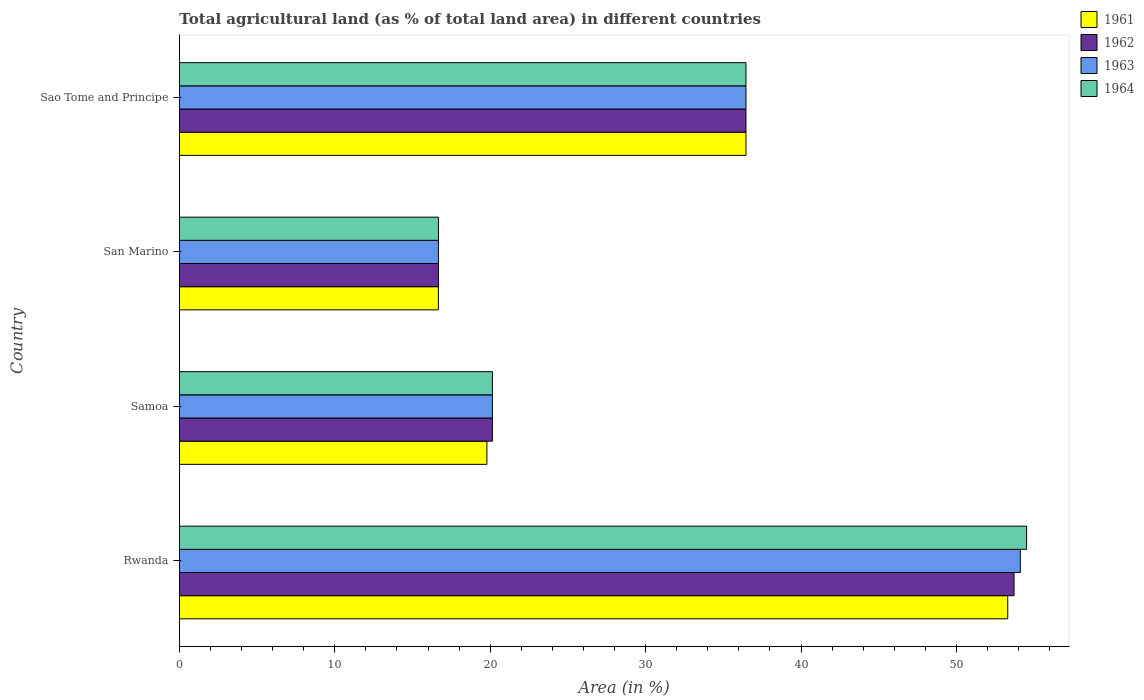Are the number of bars per tick equal to the number of legend labels?
Offer a very short reply. Yes. How many bars are there on the 4th tick from the top?
Your answer should be very brief. 4. How many bars are there on the 1st tick from the bottom?
Your response must be concise. 4. What is the label of the 1st group of bars from the top?
Ensure brevity in your answer.  Sao Tome and Principe. What is the percentage of agricultural land in 1963 in San Marino?
Your answer should be very brief. 16.67. Across all countries, what is the maximum percentage of agricultural land in 1963?
Make the answer very short. 54.11. Across all countries, what is the minimum percentage of agricultural land in 1963?
Your answer should be very brief. 16.67. In which country was the percentage of agricultural land in 1961 maximum?
Your answer should be very brief. Rwanda. In which country was the percentage of agricultural land in 1964 minimum?
Your response must be concise. San Marino. What is the total percentage of agricultural land in 1961 in the graph?
Make the answer very short. 126.22. What is the difference between the percentage of agricultural land in 1961 in Samoa and that in San Marino?
Provide a short and direct response. 3.12. What is the difference between the percentage of agricultural land in 1964 in San Marino and the percentage of agricultural land in 1961 in Rwanda?
Your response must be concise. -36.64. What is the average percentage of agricultural land in 1961 per country?
Provide a short and direct response. 31.55. What is the difference between the percentage of agricultural land in 1964 and percentage of agricultural land in 1961 in Samoa?
Make the answer very short. 0.35. What is the ratio of the percentage of agricultural land in 1962 in Rwanda to that in Sao Tome and Principe?
Your answer should be compact. 1.47. What is the difference between the highest and the second highest percentage of agricultural land in 1962?
Keep it short and to the point. 17.25. What is the difference between the highest and the lowest percentage of agricultural land in 1964?
Keep it short and to the point. 37.85. Is the sum of the percentage of agricultural land in 1961 in Rwanda and Sao Tome and Principe greater than the maximum percentage of agricultural land in 1962 across all countries?
Offer a terse response. Yes. What does the 4th bar from the top in Rwanda represents?
Give a very brief answer. 1961. Is it the case that in every country, the sum of the percentage of agricultural land in 1964 and percentage of agricultural land in 1962 is greater than the percentage of agricultural land in 1961?
Provide a succinct answer. Yes. How many countries are there in the graph?
Make the answer very short. 4. Does the graph contain grids?
Your answer should be compact. No. Where does the legend appear in the graph?
Give a very brief answer. Top right. What is the title of the graph?
Offer a very short reply. Total agricultural land (as % of total land area) in different countries. Does "1982" appear as one of the legend labels in the graph?
Keep it short and to the point. No. What is the label or title of the X-axis?
Provide a short and direct response. Area (in %). What is the Area (in %) of 1961 in Rwanda?
Offer a terse response. 53.3. What is the Area (in %) in 1962 in Rwanda?
Your response must be concise. 53.71. What is the Area (in %) of 1963 in Rwanda?
Ensure brevity in your answer.  54.11. What is the Area (in %) of 1964 in Rwanda?
Give a very brief answer. 54.52. What is the Area (in %) of 1961 in Samoa?
Ensure brevity in your answer.  19.79. What is the Area (in %) in 1962 in Samoa?
Your response must be concise. 20.14. What is the Area (in %) of 1963 in Samoa?
Your answer should be very brief. 20.14. What is the Area (in %) in 1964 in Samoa?
Your answer should be compact. 20.14. What is the Area (in %) in 1961 in San Marino?
Keep it short and to the point. 16.67. What is the Area (in %) of 1962 in San Marino?
Provide a succinct answer. 16.67. What is the Area (in %) of 1963 in San Marino?
Your response must be concise. 16.67. What is the Area (in %) in 1964 in San Marino?
Ensure brevity in your answer.  16.67. What is the Area (in %) in 1961 in Sao Tome and Principe?
Your answer should be compact. 36.46. What is the Area (in %) in 1962 in Sao Tome and Principe?
Your response must be concise. 36.46. What is the Area (in %) in 1963 in Sao Tome and Principe?
Provide a short and direct response. 36.46. What is the Area (in %) in 1964 in Sao Tome and Principe?
Your answer should be very brief. 36.46. Across all countries, what is the maximum Area (in %) in 1961?
Make the answer very short. 53.3. Across all countries, what is the maximum Area (in %) of 1962?
Your answer should be very brief. 53.71. Across all countries, what is the maximum Area (in %) of 1963?
Offer a terse response. 54.11. Across all countries, what is the maximum Area (in %) in 1964?
Provide a short and direct response. 54.52. Across all countries, what is the minimum Area (in %) in 1961?
Keep it short and to the point. 16.67. Across all countries, what is the minimum Area (in %) of 1962?
Your answer should be very brief. 16.67. Across all countries, what is the minimum Area (in %) in 1963?
Offer a terse response. 16.67. Across all countries, what is the minimum Area (in %) of 1964?
Your response must be concise. 16.67. What is the total Area (in %) in 1961 in the graph?
Offer a very short reply. 126.22. What is the total Area (in %) of 1962 in the graph?
Provide a succinct answer. 126.98. What is the total Area (in %) of 1963 in the graph?
Keep it short and to the point. 127.38. What is the total Area (in %) in 1964 in the graph?
Your answer should be very brief. 127.79. What is the difference between the Area (in %) in 1961 in Rwanda and that in Samoa?
Provide a succinct answer. 33.52. What is the difference between the Area (in %) in 1962 in Rwanda and that in Samoa?
Offer a very short reply. 33.57. What is the difference between the Area (in %) in 1963 in Rwanda and that in Samoa?
Make the answer very short. 33.97. What is the difference between the Area (in %) in 1964 in Rwanda and that in Samoa?
Give a very brief answer. 34.38. What is the difference between the Area (in %) of 1961 in Rwanda and that in San Marino?
Give a very brief answer. 36.64. What is the difference between the Area (in %) in 1962 in Rwanda and that in San Marino?
Ensure brevity in your answer.  37.04. What is the difference between the Area (in %) in 1963 in Rwanda and that in San Marino?
Provide a succinct answer. 37.45. What is the difference between the Area (in %) of 1964 in Rwanda and that in San Marino?
Provide a short and direct response. 37.85. What is the difference between the Area (in %) in 1961 in Rwanda and that in Sao Tome and Principe?
Your answer should be very brief. 16.85. What is the difference between the Area (in %) in 1962 in Rwanda and that in Sao Tome and Principe?
Ensure brevity in your answer.  17.25. What is the difference between the Area (in %) of 1963 in Rwanda and that in Sao Tome and Principe?
Your answer should be compact. 17.66. What is the difference between the Area (in %) of 1964 in Rwanda and that in Sao Tome and Principe?
Offer a very short reply. 18.06. What is the difference between the Area (in %) of 1961 in Samoa and that in San Marino?
Ensure brevity in your answer.  3.12. What is the difference between the Area (in %) of 1962 in Samoa and that in San Marino?
Offer a terse response. 3.47. What is the difference between the Area (in %) of 1963 in Samoa and that in San Marino?
Your response must be concise. 3.47. What is the difference between the Area (in %) in 1964 in Samoa and that in San Marino?
Your answer should be very brief. 3.47. What is the difference between the Area (in %) of 1961 in Samoa and that in Sao Tome and Principe?
Offer a terse response. -16.67. What is the difference between the Area (in %) of 1962 in Samoa and that in Sao Tome and Principe?
Make the answer very short. -16.32. What is the difference between the Area (in %) of 1963 in Samoa and that in Sao Tome and Principe?
Give a very brief answer. -16.32. What is the difference between the Area (in %) in 1964 in Samoa and that in Sao Tome and Principe?
Your response must be concise. -16.32. What is the difference between the Area (in %) of 1961 in San Marino and that in Sao Tome and Principe?
Your answer should be very brief. -19.79. What is the difference between the Area (in %) of 1962 in San Marino and that in Sao Tome and Principe?
Make the answer very short. -19.79. What is the difference between the Area (in %) in 1963 in San Marino and that in Sao Tome and Principe?
Ensure brevity in your answer.  -19.79. What is the difference between the Area (in %) of 1964 in San Marino and that in Sao Tome and Principe?
Your response must be concise. -19.79. What is the difference between the Area (in %) in 1961 in Rwanda and the Area (in %) in 1962 in Samoa?
Offer a terse response. 33.16. What is the difference between the Area (in %) in 1961 in Rwanda and the Area (in %) in 1963 in Samoa?
Make the answer very short. 33.16. What is the difference between the Area (in %) of 1961 in Rwanda and the Area (in %) of 1964 in Samoa?
Provide a succinct answer. 33.16. What is the difference between the Area (in %) of 1962 in Rwanda and the Area (in %) of 1963 in Samoa?
Offer a very short reply. 33.57. What is the difference between the Area (in %) of 1962 in Rwanda and the Area (in %) of 1964 in Samoa?
Your response must be concise. 33.57. What is the difference between the Area (in %) in 1963 in Rwanda and the Area (in %) in 1964 in Samoa?
Offer a terse response. 33.97. What is the difference between the Area (in %) in 1961 in Rwanda and the Area (in %) in 1962 in San Marino?
Give a very brief answer. 36.64. What is the difference between the Area (in %) in 1961 in Rwanda and the Area (in %) in 1963 in San Marino?
Keep it short and to the point. 36.64. What is the difference between the Area (in %) of 1961 in Rwanda and the Area (in %) of 1964 in San Marino?
Ensure brevity in your answer.  36.64. What is the difference between the Area (in %) of 1962 in Rwanda and the Area (in %) of 1963 in San Marino?
Your answer should be very brief. 37.04. What is the difference between the Area (in %) in 1962 in Rwanda and the Area (in %) in 1964 in San Marino?
Provide a short and direct response. 37.04. What is the difference between the Area (in %) in 1963 in Rwanda and the Area (in %) in 1964 in San Marino?
Provide a succinct answer. 37.45. What is the difference between the Area (in %) of 1961 in Rwanda and the Area (in %) of 1962 in Sao Tome and Principe?
Your answer should be very brief. 16.85. What is the difference between the Area (in %) in 1961 in Rwanda and the Area (in %) in 1963 in Sao Tome and Principe?
Give a very brief answer. 16.85. What is the difference between the Area (in %) of 1961 in Rwanda and the Area (in %) of 1964 in Sao Tome and Principe?
Keep it short and to the point. 16.85. What is the difference between the Area (in %) in 1962 in Rwanda and the Area (in %) in 1963 in Sao Tome and Principe?
Your response must be concise. 17.25. What is the difference between the Area (in %) in 1962 in Rwanda and the Area (in %) in 1964 in Sao Tome and Principe?
Give a very brief answer. 17.25. What is the difference between the Area (in %) of 1963 in Rwanda and the Area (in %) of 1964 in Sao Tome and Principe?
Ensure brevity in your answer.  17.66. What is the difference between the Area (in %) of 1961 in Samoa and the Area (in %) of 1962 in San Marino?
Your answer should be very brief. 3.12. What is the difference between the Area (in %) in 1961 in Samoa and the Area (in %) in 1963 in San Marino?
Your response must be concise. 3.12. What is the difference between the Area (in %) of 1961 in Samoa and the Area (in %) of 1964 in San Marino?
Your answer should be very brief. 3.12. What is the difference between the Area (in %) of 1962 in Samoa and the Area (in %) of 1963 in San Marino?
Your answer should be very brief. 3.47. What is the difference between the Area (in %) of 1962 in Samoa and the Area (in %) of 1964 in San Marino?
Make the answer very short. 3.47. What is the difference between the Area (in %) of 1963 in Samoa and the Area (in %) of 1964 in San Marino?
Keep it short and to the point. 3.47. What is the difference between the Area (in %) of 1961 in Samoa and the Area (in %) of 1962 in Sao Tome and Principe?
Provide a short and direct response. -16.67. What is the difference between the Area (in %) of 1961 in Samoa and the Area (in %) of 1963 in Sao Tome and Principe?
Provide a succinct answer. -16.67. What is the difference between the Area (in %) of 1961 in Samoa and the Area (in %) of 1964 in Sao Tome and Principe?
Your answer should be compact. -16.67. What is the difference between the Area (in %) in 1962 in Samoa and the Area (in %) in 1963 in Sao Tome and Principe?
Your answer should be very brief. -16.32. What is the difference between the Area (in %) of 1962 in Samoa and the Area (in %) of 1964 in Sao Tome and Principe?
Make the answer very short. -16.32. What is the difference between the Area (in %) of 1963 in Samoa and the Area (in %) of 1964 in Sao Tome and Principe?
Provide a succinct answer. -16.32. What is the difference between the Area (in %) of 1961 in San Marino and the Area (in %) of 1962 in Sao Tome and Principe?
Keep it short and to the point. -19.79. What is the difference between the Area (in %) in 1961 in San Marino and the Area (in %) in 1963 in Sao Tome and Principe?
Your answer should be compact. -19.79. What is the difference between the Area (in %) of 1961 in San Marino and the Area (in %) of 1964 in Sao Tome and Principe?
Make the answer very short. -19.79. What is the difference between the Area (in %) in 1962 in San Marino and the Area (in %) in 1963 in Sao Tome and Principe?
Give a very brief answer. -19.79. What is the difference between the Area (in %) of 1962 in San Marino and the Area (in %) of 1964 in Sao Tome and Principe?
Your response must be concise. -19.79. What is the difference between the Area (in %) of 1963 in San Marino and the Area (in %) of 1964 in Sao Tome and Principe?
Your answer should be compact. -19.79. What is the average Area (in %) of 1961 per country?
Give a very brief answer. 31.55. What is the average Area (in %) in 1962 per country?
Offer a very short reply. 31.74. What is the average Area (in %) of 1963 per country?
Your answer should be compact. 31.85. What is the average Area (in %) of 1964 per country?
Offer a terse response. 31.95. What is the difference between the Area (in %) of 1961 and Area (in %) of 1962 in Rwanda?
Your response must be concise. -0.41. What is the difference between the Area (in %) in 1961 and Area (in %) in 1963 in Rwanda?
Provide a succinct answer. -0.81. What is the difference between the Area (in %) of 1961 and Area (in %) of 1964 in Rwanda?
Keep it short and to the point. -1.22. What is the difference between the Area (in %) in 1962 and Area (in %) in 1963 in Rwanda?
Offer a terse response. -0.41. What is the difference between the Area (in %) in 1962 and Area (in %) in 1964 in Rwanda?
Provide a succinct answer. -0.81. What is the difference between the Area (in %) of 1963 and Area (in %) of 1964 in Rwanda?
Keep it short and to the point. -0.41. What is the difference between the Area (in %) in 1961 and Area (in %) in 1962 in Samoa?
Offer a very short reply. -0.35. What is the difference between the Area (in %) in 1961 and Area (in %) in 1963 in Samoa?
Make the answer very short. -0.35. What is the difference between the Area (in %) in 1961 and Area (in %) in 1964 in Samoa?
Give a very brief answer. -0.35. What is the difference between the Area (in %) in 1961 and Area (in %) in 1962 in San Marino?
Make the answer very short. 0. What is the difference between the Area (in %) of 1961 and Area (in %) of 1963 in San Marino?
Offer a very short reply. 0. What is the difference between the Area (in %) of 1961 and Area (in %) of 1964 in San Marino?
Keep it short and to the point. 0. What is the difference between the Area (in %) in 1962 and Area (in %) in 1963 in San Marino?
Offer a very short reply. 0. What is the ratio of the Area (in %) of 1961 in Rwanda to that in Samoa?
Provide a short and direct response. 2.69. What is the ratio of the Area (in %) of 1962 in Rwanda to that in Samoa?
Make the answer very short. 2.67. What is the ratio of the Area (in %) in 1963 in Rwanda to that in Samoa?
Provide a succinct answer. 2.69. What is the ratio of the Area (in %) in 1964 in Rwanda to that in Samoa?
Make the answer very short. 2.71. What is the ratio of the Area (in %) in 1961 in Rwanda to that in San Marino?
Make the answer very short. 3.2. What is the ratio of the Area (in %) in 1962 in Rwanda to that in San Marino?
Provide a succinct answer. 3.22. What is the ratio of the Area (in %) of 1963 in Rwanda to that in San Marino?
Ensure brevity in your answer.  3.25. What is the ratio of the Area (in %) in 1964 in Rwanda to that in San Marino?
Your answer should be very brief. 3.27. What is the ratio of the Area (in %) of 1961 in Rwanda to that in Sao Tome and Principe?
Keep it short and to the point. 1.46. What is the ratio of the Area (in %) of 1962 in Rwanda to that in Sao Tome and Principe?
Provide a succinct answer. 1.47. What is the ratio of the Area (in %) in 1963 in Rwanda to that in Sao Tome and Principe?
Your response must be concise. 1.48. What is the ratio of the Area (in %) of 1964 in Rwanda to that in Sao Tome and Principe?
Make the answer very short. 1.5. What is the ratio of the Area (in %) in 1961 in Samoa to that in San Marino?
Ensure brevity in your answer.  1.19. What is the ratio of the Area (in %) in 1962 in Samoa to that in San Marino?
Ensure brevity in your answer.  1.21. What is the ratio of the Area (in %) in 1963 in Samoa to that in San Marino?
Your answer should be very brief. 1.21. What is the ratio of the Area (in %) of 1964 in Samoa to that in San Marino?
Provide a short and direct response. 1.21. What is the ratio of the Area (in %) in 1961 in Samoa to that in Sao Tome and Principe?
Provide a succinct answer. 0.54. What is the ratio of the Area (in %) in 1962 in Samoa to that in Sao Tome and Principe?
Your response must be concise. 0.55. What is the ratio of the Area (in %) of 1963 in Samoa to that in Sao Tome and Principe?
Provide a short and direct response. 0.55. What is the ratio of the Area (in %) of 1964 in Samoa to that in Sao Tome and Principe?
Make the answer very short. 0.55. What is the ratio of the Area (in %) in 1961 in San Marino to that in Sao Tome and Principe?
Provide a short and direct response. 0.46. What is the ratio of the Area (in %) of 1962 in San Marino to that in Sao Tome and Principe?
Give a very brief answer. 0.46. What is the ratio of the Area (in %) in 1963 in San Marino to that in Sao Tome and Principe?
Keep it short and to the point. 0.46. What is the ratio of the Area (in %) in 1964 in San Marino to that in Sao Tome and Principe?
Provide a short and direct response. 0.46. What is the difference between the highest and the second highest Area (in %) in 1961?
Your answer should be compact. 16.85. What is the difference between the highest and the second highest Area (in %) in 1962?
Provide a succinct answer. 17.25. What is the difference between the highest and the second highest Area (in %) in 1963?
Keep it short and to the point. 17.66. What is the difference between the highest and the second highest Area (in %) of 1964?
Provide a succinct answer. 18.06. What is the difference between the highest and the lowest Area (in %) of 1961?
Make the answer very short. 36.64. What is the difference between the highest and the lowest Area (in %) in 1962?
Give a very brief answer. 37.04. What is the difference between the highest and the lowest Area (in %) in 1963?
Your response must be concise. 37.45. What is the difference between the highest and the lowest Area (in %) of 1964?
Your response must be concise. 37.85. 